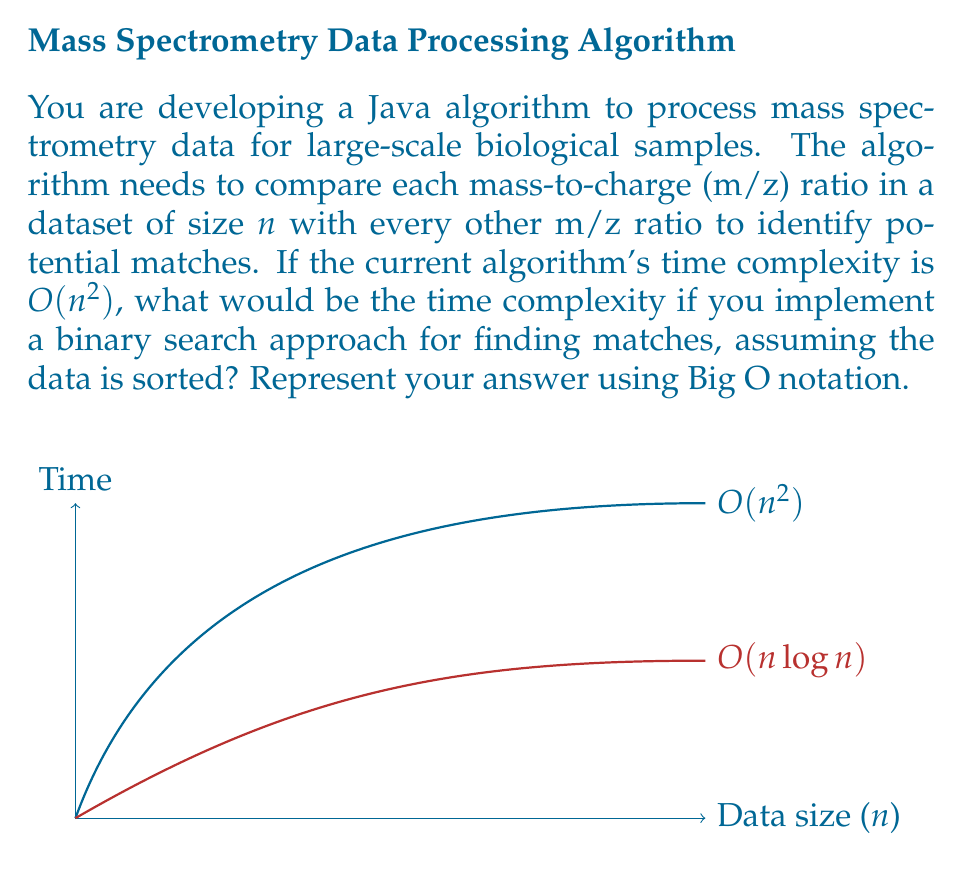Teach me how to tackle this problem. Let's approach this step-by-step:

1. The current algorithm compares each m/z ratio with every other ratio, resulting in a time complexity of $O(n^2)$. This is because for each of the $n$ elements, it performs $n$ comparisons.

2. By implementing a binary search approach, we can significantly reduce the number of comparisons needed for each element.

3. Binary search has a time complexity of $O(\log n)$ for a single search operation in a sorted array of size $n$.

4. In the optimized algorithm, we still need to perform a search for each of the $n$ elements in the dataset.

5. For each element, instead of comparing with all $n$ elements, we now perform a binary search, which takes $O(\log n)$ time.

6. Therefore, the overall time complexity becomes:
   $$ O(n \cdot \log n) $$

   This is because we perform $n$ binary searches, each taking $O(\log n)$ time.

7. The time complexity $O(n \log n)$ is significantly better than $O(n^2)$ for large datasets, as shown in the graph in the question.

8. Note: This assumes that the initial sorting of the data (which is necessary for binary search) is done separately or as a pre-processing step. If we include the sorting step, the overall complexity would still be $O(n \log n)$, as efficient sorting algorithms like QuickSort or MergeSort also have a time complexity of $O(n \log n)$.
Answer: $O(n \log n)$ 